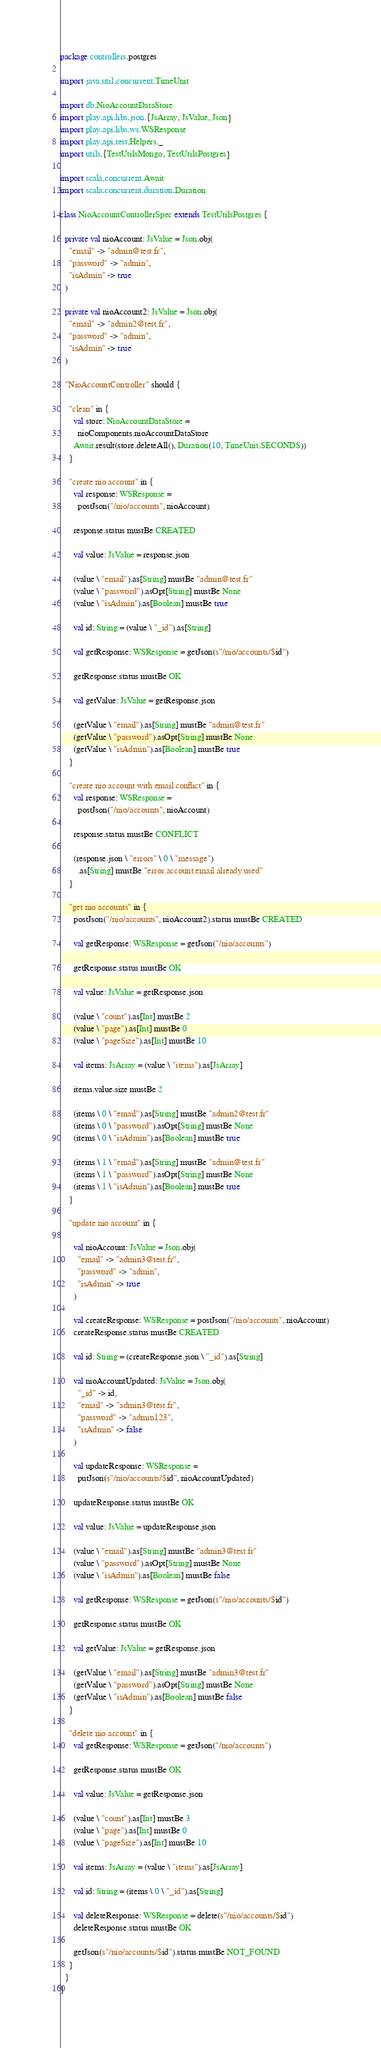<code> <loc_0><loc_0><loc_500><loc_500><_Scala_>package controllers.postgres

import java.util.concurrent.TimeUnit

import db.NioAccountDataStore
import play.api.libs.json.{JsArray, JsValue, Json}
import play.api.libs.ws.WSResponse
import play.api.test.Helpers._
import utils.{TestUtilsMongo, TestUtilsPostgres}

import scala.concurrent.Await
import scala.concurrent.duration.Duration

class NioAccountControllerSpec extends TestUtilsPostgres {

  private val nioAccount: JsValue = Json.obj(
    "email" -> "admin@test.fr",
    "password" -> "admin",
    "isAdmin" -> true
  )

  private val nioAccount2: JsValue = Json.obj(
    "email" -> "admin2@test.fr",
    "password" -> "admin",
    "isAdmin" -> true
  )

  "NioAccountController" should {

    "clean" in {
      val store: NioAccountDataStore =
        nioComponents.nioAccountDataStore
      Await.result(store.deleteAll(), Duration(10, TimeUnit.SECONDS))
    }

    "create nio account" in {
      val response: WSResponse =
        postJson("/nio/accounts", nioAccount)

      response.status mustBe CREATED

      val value: JsValue = response.json

      (value \ "email").as[String] mustBe "admin@test.fr"
      (value \ "password").asOpt[String] mustBe None
      (value \ "isAdmin").as[Boolean] mustBe true

      val id: String = (value \ "_id").as[String]

      val getResponse: WSResponse = getJson(s"/nio/accounts/$id")

      getResponse.status mustBe OK

      val getValue: JsValue = getResponse.json

      (getValue \ "email").as[String] mustBe "admin@test.fr"
      (getValue \ "password").asOpt[String] mustBe None
      (getValue \ "isAdmin").as[Boolean] mustBe true
    }

    "create nio account with email conflict" in {
      val response: WSResponse =
        postJson("/nio/accounts", nioAccount)

      response.status mustBe CONFLICT

      (response.json \ "errors" \ 0 \ "message")
        .as[String] mustBe "error.account.email.already.used"
    }

    "get nio accounts" in {
      postJson("/nio/accounts", nioAccount2).status mustBe CREATED

      val getResponse: WSResponse = getJson("/nio/accounts")

      getResponse.status mustBe OK

      val value: JsValue = getResponse.json

      (value \ "count").as[Int] mustBe 2
      (value \ "page").as[Int] mustBe 0
      (value \ "pageSize").as[Int] mustBe 10

      val items: JsArray = (value \ "items").as[JsArray]

      items.value.size mustBe 2

      (items \ 0 \ "email").as[String] mustBe "admin2@test.fr"
      (items \ 0 \ "password").asOpt[String] mustBe None
      (items \ 0 \ "isAdmin").as[Boolean] mustBe true

      (items \ 1 \ "email").as[String] mustBe "admin@test.fr"
      (items \ 1 \ "password").asOpt[String] mustBe None
      (items \ 1 \ "isAdmin").as[Boolean] mustBe true
    }

    "update nio account" in {

      val nioAccount: JsValue = Json.obj(
        "email" -> "admin3@test.fr",
        "password" -> "admin",
        "isAdmin" -> true
      )

      val createResponse: WSResponse = postJson("/nio/accounts", nioAccount)
      createResponse.status mustBe CREATED

      val id: String = (createResponse.json \ "_id").as[String]

      val nioAccountUpdated: JsValue = Json.obj(
        "_id" -> id,
        "email" -> "admin3@test.fr",
        "password" -> "admin123",
        "isAdmin" -> false
      )

      val updateResponse: WSResponse =
        putJson(s"/nio/accounts/$id", nioAccountUpdated)

      updateResponse.status mustBe OK

      val value: JsValue = updateResponse.json

      (value \ "email").as[String] mustBe "admin3@test.fr"
      (value \ "password").asOpt[String] mustBe None
      (value \ "isAdmin").as[Boolean] mustBe false

      val getResponse: WSResponse = getJson(s"/nio/accounts/$id")

      getResponse.status mustBe OK

      val getValue: JsValue = getResponse.json

      (getValue \ "email").as[String] mustBe "admin3@test.fr"
      (getValue \ "password").asOpt[String] mustBe None
      (getValue \ "isAdmin").as[Boolean] mustBe false
    }

    "delete nio account" in {
      val getResponse: WSResponse = getJson("/nio/accounts")

      getResponse.status mustBe OK

      val value: JsValue = getResponse.json

      (value \ "count").as[Int] mustBe 3
      (value \ "page").as[Int] mustBe 0
      (value \ "pageSize").as[Int] mustBe 10

      val items: JsArray = (value \ "items").as[JsArray]

      val id: String = (items \ 0 \ "_id").as[String]

      val deleteResponse: WSResponse = delete(s"/nio/accounts/$id")
      deleteResponse.status mustBe OK

      getJson(s"/nio/accounts/$id").status mustBe NOT_FOUND
    }
  }
}
</code> 